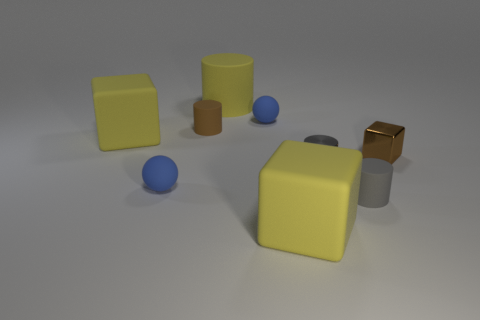The metallic block has what color? The image shows a metallic block at the right, which has a reflective bronze hue, with a distinct shine that highlights its metallic characteristics. 